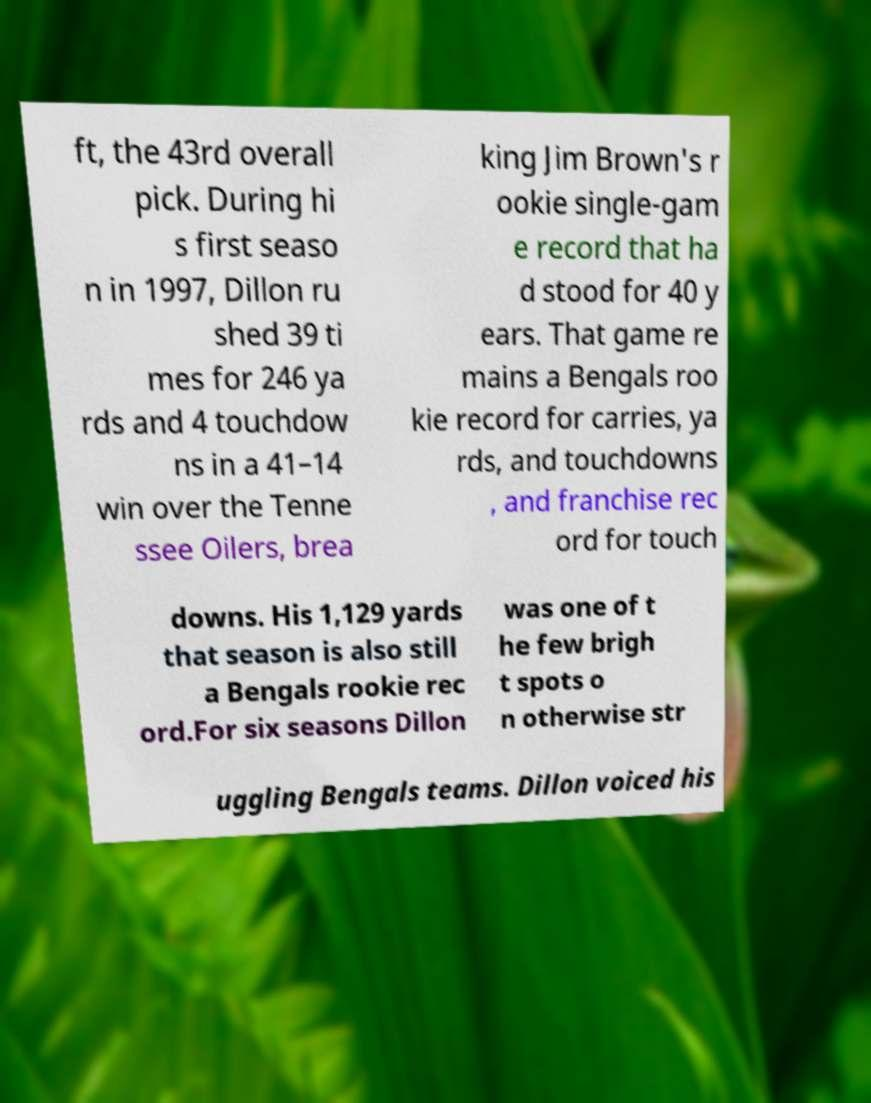Please read and relay the text visible in this image. What does it say? ft, the 43rd overall pick. During hi s first seaso n in 1997, Dillon ru shed 39 ti mes for 246 ya rds and 4 touchdow ns in a 41–14 win over the Tenne ssee Oilers, brea king Jim Brown's r ookie single-gam e record that ha d stood for 40 y ears. That game re mains a Bengals roo kie record for carries, ya rds, and touchdowns , and franchise rec ord for touch downs. His 1,129 yards that season is also still a Bengals rookie rec ord.For six seasons Dillon was one of t he few brigh t spots o n otherwise str uggling Bengals teams. Dillon voiced his 